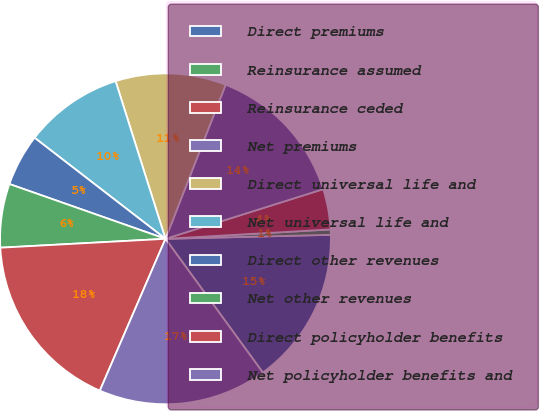Convert chart to OTSL. <chart><loc_0><loc_0><loc_500><loc_500><pie_chart><fcel>Direct premiums<fcel>Reinsurance assumed<fcel>Reinsurance ceded<fcel>Net premiums<fcel>Direct universal life and<fcel>Net universal life and<fcel>Direct other revenues<fcel>Net other revenues<fcel>Direct policyholder benefits<fcel>Net policyholder benefits and<nl><fcel>15.37%<fcel>0.52%<fcel>3.95%<fcel>14.22%<fcel>10.8%<fcel>9.66%<fcel>5.09%<fcel>6.23%<fcel>17.65%<fcel>16.51%<nl></chart> 